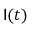Convert formula to latex. <formula><loc_0><loc_0><loc_500><loc_500>I ( t )</formula> 